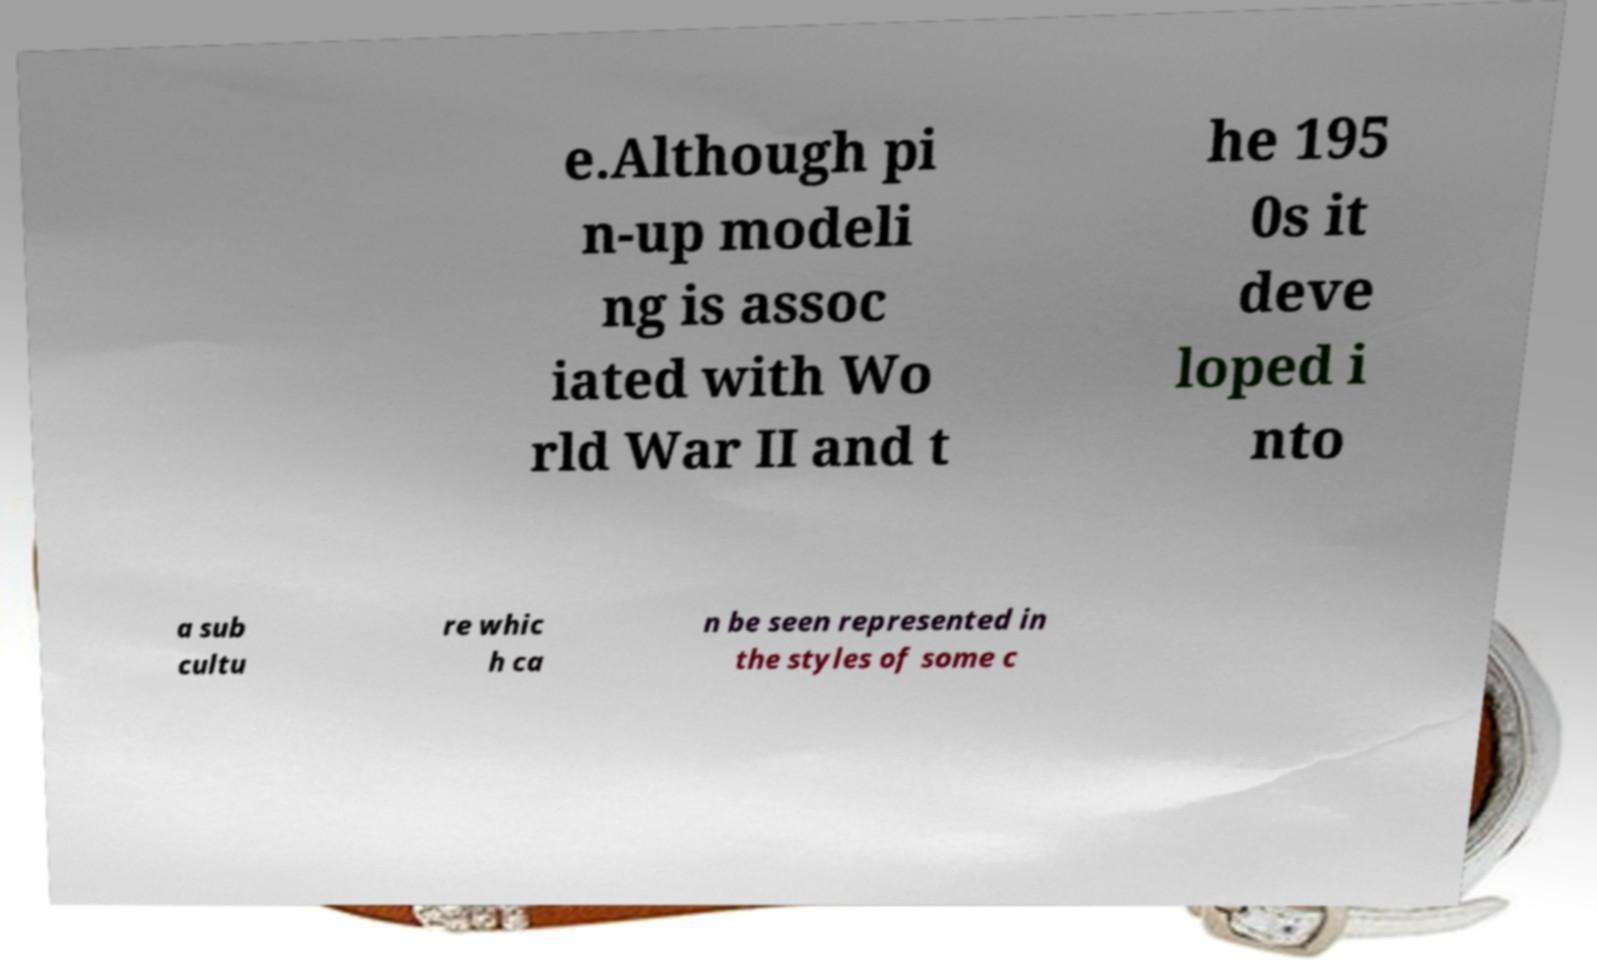I need the written content from this picture converted into text. Can you do that? e.Although pi n-up modeli ng is assoc iated with Wo rld War II and t he 195 0s it deve loped i nto a sub cultu re whic h ca n be seen represented in the styles of some c 